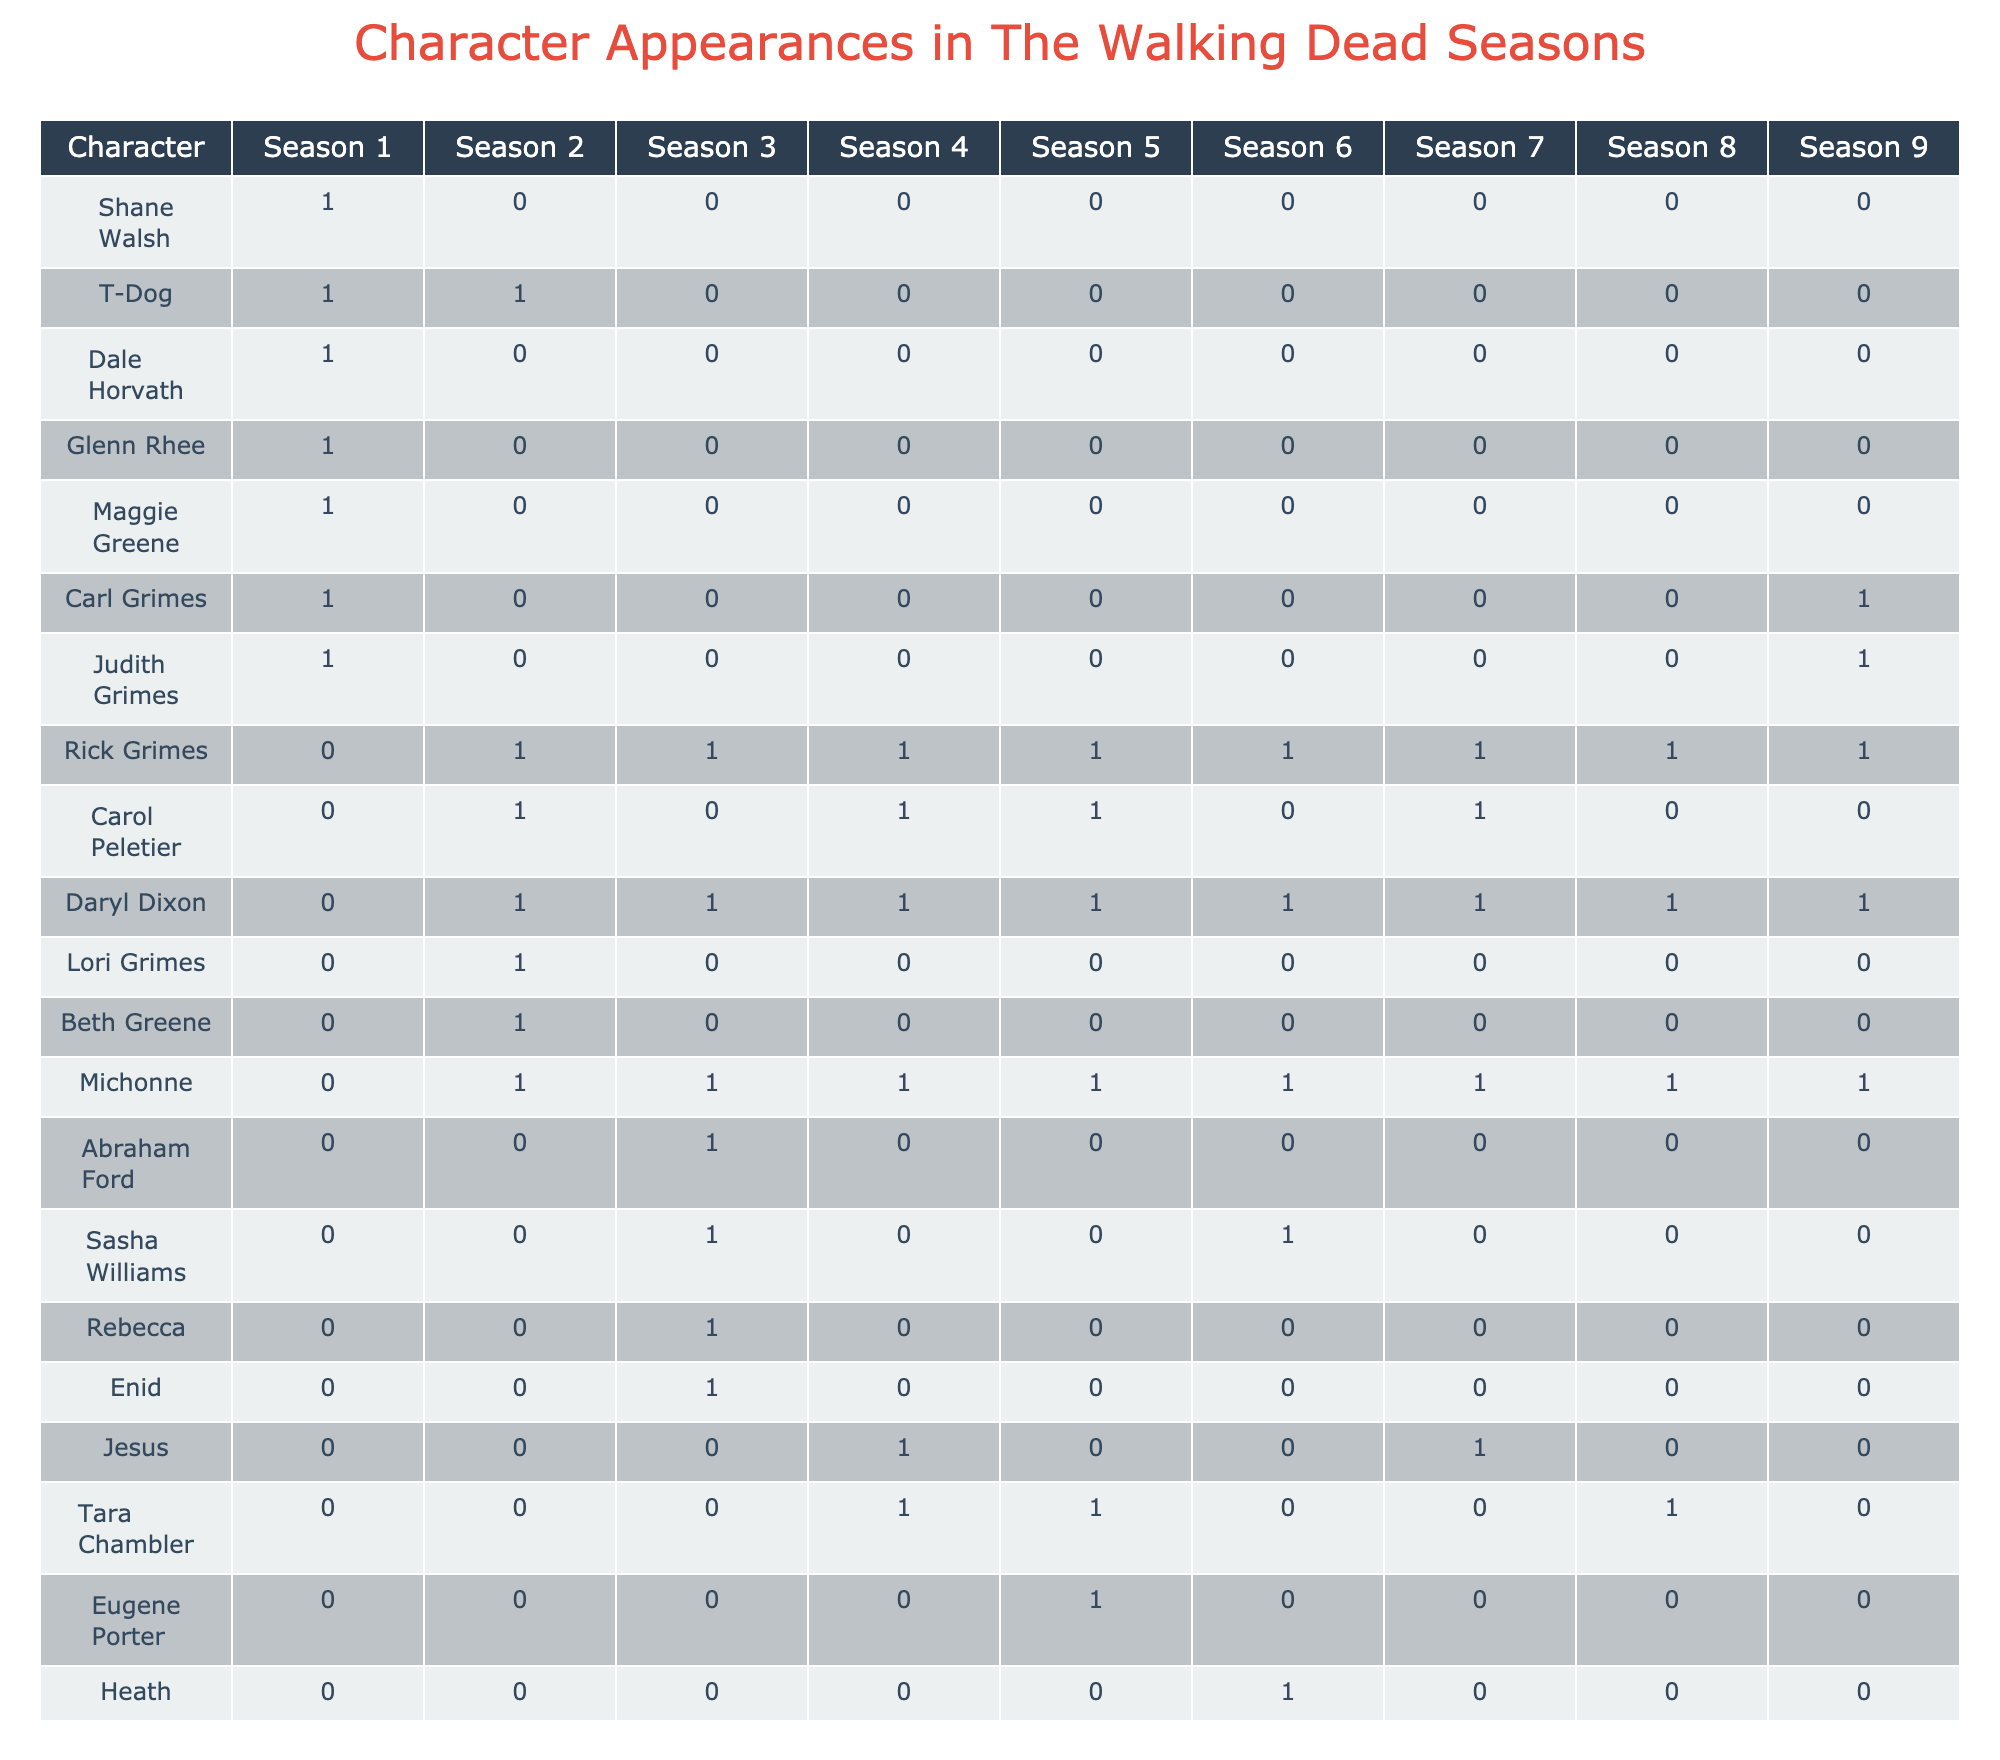What character appears in the most seasons? By looking across the seasons, I can see which characters have a '1' marked for most of the columns. I count the appearances for each character and find that Rick Grimes appears in all 9 seasons.
Answer: Rick Grimes Which character was a protagonist in season 3? In season 3, I can find the roles for each character. By checking the row for season 3, I see that Rick Grimes, Daryl Dixon, and Michonne are listed as protagonists.
Answer: Rick Grimes, Daryl Dixon, Michonne How many female characters appear throughout the seasons? I review each character's gender and tally the female characters listed. Counting them shows that there are 8 female characters in total across all seasons.
Answer: 8 What is the proportion of Black characters to total characters in season 5? To find this proportion, I first count the total characters in season 5, which is 6. Then I count the Black characters, which is 2 (Michonne and Tara). The proportion is therefore 2 out of 6, simplifying to 1 out of 3.
Answer: 1/3 Does Daryl Dixon have a supporting role in any season? By scanning through the table's entries for Daryl Dixon’s role, I can see that he is listed as a protagonist in all seasons he appears without any occurrence of a supporting role. Hence, the answer is no.
Answer: No Which season has the highest number of characters shown? I look at the counts of unique characters in each season and see that season 1 has 8 unique characters, which is the highest.
Answer: Season 1 What's the average age group of the protagonists across all seasons? I identify the age groups of all protagonists listed in each season. The age groups are Adult, Young Adult, and Child. Counting them gives me 7 Adult, 5 Young Adult, and 1 Child. There are 13 protagonists total, and the average corresponds to the age group leaning towards Adult.
Answer: Adult Are there any antagonists in every season? Checking the rows for antagonists, I review the unique characters listed as antagonists, seeing that only Negan (season 8) and Alpha (season 9) appear, meaning there are no antagonists present in every season.
Answer: No How many characters appear in both season 2 and season 5? I list out the characters for both season 2 and season 5 and find overlapping appearances. Comparing the two shows 3 characters are present in both: Daryl Dixon, Rick Grimes, and Carol Peletier.
Answer: 3 What is the difference in the number of Asian characters between seasons 1 and 9? I look at the appearances of Asian characters in both seasons. In season 1, there is 1 Asian character (Glenn) and in season 9, there are none. Therefore, the difference is 1 - 0 = 1.
Answer: 1 